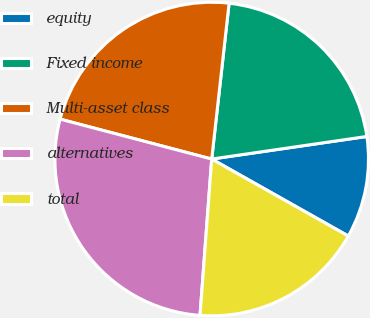<chart> <loc_0><loc_0><loc_500><loc_500><pie_chart><fcel>equity<fcel>Fixed income<fcel>Multi-asset class<fcel>alternatives<fcel>total<nl><fcel>10.47%<fcel>20.93%<fcel>22.67%<fcel>27.91%<fcel>18.02%<nl></chart> 